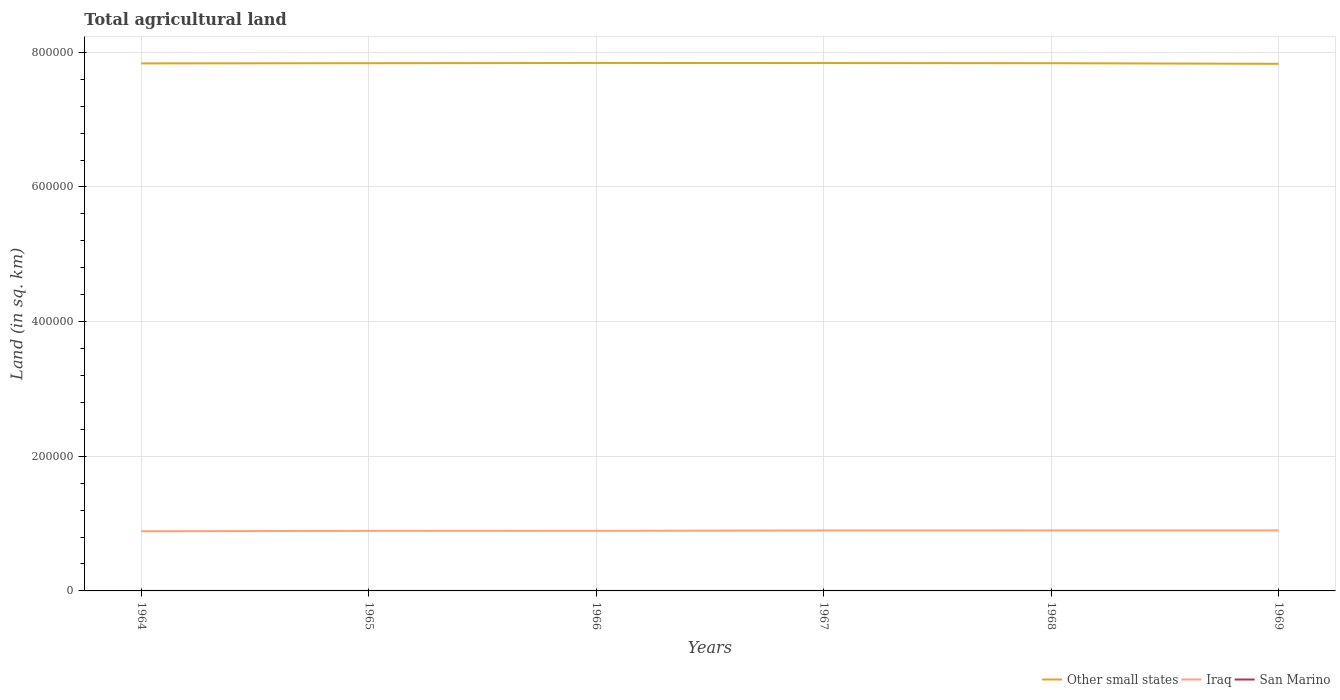How many different coloured lines are there?
Offer a terse response. 3. Is the number of lines equal to the number of legend labels?
Offer a very short reply. Yes. Across all years, what is the maximum total agricultural land in San Marino?
Ensure brevity in your answer.  10. In which year was the total agricultural land in Iraq maximum?
Provide a short and direct response. 1964. What is the difference between the highest and the second highest total agricultural land in Iraq?
Ensure brevity in your answer.  1250. What is the difference between the highest and the lowest total agricultural land in San Marino?
Your answer should be very brief. 0. Is the total agricultural land in Other small states strictly greater than the total agricultural land in Iraq over the years?
Offer a terse response. No. Are the values on the major ticks of Y-axis written in scientific E-notation?
Your answer should be compact. No. Does the graph contain any zero values?
Your answer should be very brief. No. Where does the legend appear in the graph?
Ensure brevity in your answer.  Bottom right. How many legend labels are there?
Offer a very short reply. 3. What is the title of the graph?
Your answer should be very brief. Total agricultural land. What is the label or title of the X-axis?
Ensure brevity in your answer.  Years. What is the label or title of the Y-axis?
Provide a short and direct response. Land (in sq. km). What is the Land (in sq. km) of Other small states in 1964?
Provide a short and direct response. 7.84e+05. What is the Land (in sq. km) of Iraq in 1964?
Give a very brief answer. 8.86e+04. What is the Land (in sq. km) in Other small states in 1965?
Your answer should be very brief. 7.84e+05. What is the Land (in sq. km) in Iraq in 1965?
Ensure brevity in your answer.  8.92e+04. What is the Land (in sq. km) of San Marino in 1965?
Offer a very short reply. 10. What is the Land (in sq. km) in Other small states in 1966?
Your response must be concise. 7.84e+05. What is the Land (in sq. km) in Iraq in 1966?
Your answer should be compact. 8.92e+04. What is the Land (in sq. km) in Other small states in 1967?
Make the answer very short. 7.84e+05. What is the Land (in sq. km) in Iraq in 1967?
Make the answer very short. 8.98e+04. What is the Land (in sq. km) of San Marino in 1967?
Your response must be concise. 10. What is the Land (in sq. km) of Other small states in 1968?
Make the answer very short. 7.84e+05. What is the Land (in sq. km) of Iraq in 1968?
Offer a very short reply. 8.98e+04. What is the Land (in sq. km) of Other small states in 1969?
Your answer should be very brief. 7.83e+05. What is the Land (in sq. km) of Iraq in 1969?
Your answer should be very brief. 8.99e+04. Across all years, what is the maximum Land (in sq. km) of Other small states?
Give a very brief answer. 7.84e+05. Across all years, what is the maximum Land (in sq. km) in Iraq?
Provide a short and direct response. 8.99e+04. Across all years, what is the maximum Land (in sq. km) in San Marino?
Your answer should be compact. 10. Across all years, what is the minimum Land (in sq. km) in Other small states?
Keep it short and to the point. 7.83e+05. Across all years, what is the minimum Land (in sq. km) in Iraq?
Offer a very short reply. 8.86e+04. What is the total Land (in sq. km) of Other small states in the graph?
Your answer should be compact. 4.70e+06. What is the total Land (in sq. km) in Iraq in the graph?
Make the answer very short. 5.37e+05. What is the total Land (in sq. km) in San Marino in the graph?
Ensure brevity in your answer.  60. What is the difference between the Land (in sq. km) of Other small states in 1964 and that in 1965?
Ensure brevity in your answer.  -270. What is the difference between the Land (in sq. km) in Iraq in 1964 and that in 1965?
Your answer should be very brief. -550. What is the difference between the Land (in sq. km) of San Marino in 1964 and that in 1965?
Offer a terse response. 0. What is the difference between the Land (in sq. km) in Other small states in 1964 and that in 1966?
Ensure brevity in your answer.  -610. What is the difference between the Land (in sq. km) in Iraq in 1964 and that in 1966?
Your answer should be very brief. -600. What is the difference between the Land (in sq. km) of San Marino in 1964 and that in 1966?
Offer a terse response. 0. What is the difference between the Land (in sq. km) of Other small states in 1964 and that in 1967?
Offer a terse response. -530. What is the difference between the Land (in sq. km) of Iraq in 1964 and that in 1967?
Keep it short and to the point. -1150. What is the difference between the Land (in sq. km) of San Marino in 1964 and that in 1967?
Your answer should be compact. 0. What is the difference between the Land (in sq. km) of Other small states in 1964 and that in 1968?
Your answer should be very brief. -270. What is the difference between the Land (in sq. km) of Iraq in 1964 and that in 1968?
Give a very brief answer. -1200. What is the difference between the Land (in sq. km) of Other small states in 1964 and that in 1969?
Give a very brief answer. 640. What is the difference between the Land (in sq. km) in Iraq in 1964 and that in 1969?
Give a very brief answer. -1250. What is the difference between the Land (in sq. km) of San Marino in 1964 and that in 1969?
Give a very brief answer. 0. What is the difference between the Land (in sq. km) in Other small states in 1965 and that in 1966?
Make the answer very short. -340. What is the difference between the Land (in sq. km) in Other small states in 1965 and that in 1967?
Offer a terse response. -260. What is the difference between the Land (in sq. km) of Iraq in 1965 and that in 1967?
Your response must be concise. -600. What is the difference between the Land (in sq. km) of Other small states in 1965 and that in 1968?
Ensure brevity in your answer.  0. What is the difference between the Land (in sq. km) of Iraq in 1965 and that in 1968?
Provide a short and direct response. -650. What is the difference between the Land (in sq. km) of Other small states in 1965 and that in 1969?
Your response must be concise. 910. What is the difference between the Land (in sq. km) in Iraq in 1965 and that in 1969?
Your answer should be very brief. -700. What is the difference between the Land (in sq. km) in San Marino in 1965 and that in 1969?
Make the answer very short. 0. What is the difference between the Land (in sq. km) of Iraq in 1966 and that in 1967?
Ensure brevity in your answer.  -550. What is the difference between the Land (in sq. km) in San Marino in 1966 and that in 1967?
Make the answer very short. 0. What is the difference between the Land (in sq. km) in Other small states in 1966 and that in 1968?
Your answer should be very brief. 340. What is the difference between the Land (in sq. km) of Iraq in 1966 and that in 1968?
Your response must be concise. -600. What is the difference between the Land (in sq. km) in Other small states in 1966 and that in 1969?
Your answer should be compact. 1250. What is the difference between the Land (in sq. km) of Iraq in 1966 and that in 1969?
Give a very brief answer. -650. What is the difference between the Land (in sq. km) of Other small states in 1967 and that in 1968?
Provide a short and direct response. 260. What is the difference between the Land (in sq. km) of Iraq in 1967 and that in 1968?
Provide a short and direct response. -50. What is the difference between the Land (in sq. km) in Other small states in 1967 and that in 1969?
Keep it short and to the point. 1170. What is the difference between the Land (in sq. km) of Iraq in 1967 and that in 1969?
Offer a very short reply. -100. What is the difference between the Land (in sq. km) of San Marino in 1967 and that in 1969?
Offer a very short reply. 0. What is the difference between the Land (in sq. km) in Other small states in 1968 and that in 1969?
Make the answer very short. 910. What is the difference between the Land (in sq. km) in Other small states in 1964 and the Land (in sq. km) in Iraq in 1965?
Keep it short and to the point. 6.94e+05. What is the difference between the Land (in sq. km) of Other small states in 1964 and the Land (in sq. km) of San Marino in 1965?
Your answer should be very brief. 7.84e+05. What is the difference between the Land (in sq. km) of Iraq in 1964 and the Land (in sq. km) of San Marino in 1965?
Provide a succinct answer. 8.86e+04. What is the difference between the Land (in sq. km) of Other small states in 1964 and the Land (in sq. km) of Iraq in 1966?
Your answer should be very brief. 6.94e+05. What is the difference between the Land (in sq. km) of Other small states in 1964 and the Land (in sq. km) of San Marino in 1966?
Provide a succinct answer. 7.84e+05. What is the difference between the Land (in sq. km) in Iraq in 1964 and the Land (in sq. km) in San Marino in 1966?
Offer a terse response. 8.86e+04. What is the difference between the Land (in sq. km) in Other small states in 1964 and the Land (in sq. km) in Iraq in 1967?
Offer a terse response. 6.94e+05. What is the difference between the Land (in sq. km) of Other small states in 1964 and the Land (in sq. km) of San Marino in 1967?
Offer a very short reply. 7.84e+05. What is the difference between the Land (in sq. km) in Iraq in 1964 and the Land (in sq. km) in San Marino in 1967?
Your response must be concise. 8.86e+04. What is the difference between the Land (in sq. km) in Other small states in 1964 and the Land (in sq. km) in Iraq in 1968?
Offer a very short reply. 6.94e+05. What is the difference between the Land (in sq. km) of Other small states in 1964 and the Land (in sq. km) of San Marino in 1968?
Your response must be concise. 7.84e+05. What is the difference between the Land (in sq. km) of Iraq in 1964 and the Land (in sq. km) of San Marino in 1968?
Provide a succinct answer. 8.86e+04. What is the difference between the Land (in sq. km) in Other small states in 1964 and the Land (in sq. km) in Iraq in 1969?
Your answer should be compact. 6.94e+05. What is the difference between the Land (in sq. km) of Other small states in 1964 and the Land (in sq. km) of San Marino in 1969?
Give a very brief answer. 7.84e+05. What is the difference between the Land (in sq. km) in Iraq in 1964 and the Land (in sq. km) in San Marino in 1969?
Provide a short and direct response. 8.86e+04. What is the difference between the Land (in sq. km) in Other small states in 1965 and the Land (in sq. km) in Iraq in 1966?
Provide a short and direct response. 6.95e+05. What is the difference between the Land (in sq. km) of Other small states in 1965 and the Land (in sq. km) of San Marino in 1966?
Ensure brevity in your answer.  7.84e+05. What is the difference between the Land (in sq. km) of Iraq in 1965 and the Land (in sq. km) of San Marino in 1966?
Provide a short and direct response. 8.92e+04. What is the difference between the Land (in sq. km) of Other small states in 1965 and the Land (in sq. km) of Iraq in 1967?
Offer a very short reply. 6.94e+05. What is the difference between the Land (in sq. km) in Other small states in 1965 and the Land (in sq. km) in San Marino in 1967?
Your answer should be very brief. 7.84e+05. What is the difference between the Land (in sq. km) in Iraq in 1965 and the Land (in sq. km) in San Marino in 1967?
Make the answer very short. 8.92e+04. What is the difference between the Land (in sq. km) in Other small states in 1965 and the Land (in sq. km) in Iraq in 1968?
Give a very brief answer. 6.94e+05. What is the difference between the Land (in sq. km) in Other small states in 1965 and the Land (in sq. km) in San Marino in 1968?
Your response must be concise. 7.84e+05. What is the difference between the Land (in sq. km) in Iraq in 1965 and the Land (in sq. km) in San Marino in 1968?
Your response must be concise. 8.92e+04. What is the difference between the Land (in sq. km) of Other small states in 1965 and the Land (in sq. km) of Iraq in 1969?
Keep it short and to the point. 6.94e+05. What is the difference between the Land (in sq. km) of Other small states in 1965 and the Land (in sq. km) of San Marino in 1969?
Make the answer very short. 7.84e+05. What is the difference between the Land (in sq. km) in Iraq in 1965 and the Land (in sq. km) in San Marino in 1969?
Keep it short and to the point. 8.92e+04. What is the difference between the Land (in sq. km) in Other small states in 1966 and the Land (in sq. km) in Iraq in 1967?
Offer a terse response. 6.94e+05. What is the difference between the Land (in sq. km) in Other small states in 1966 and the Land (in sq. km) in San Marino in 1967?
Offer a terse response. 7.84e+05. What is the difference between the Land (in sq. km) of Iraq in 1966 and the Land (in sq. km) of San Marino in 1967?
Your answer should be compact. 8.92e+04. What is the difference between the Land (in sq. km) of Other small states in 1966 and the Land (in sq. km) of Iraq in 1968?
Your answer should be compact. 6.94e+05. What is the difference between the Land (in sq. km) in Other small states in 1966 and the Land (in sq. km) in San Marino in 1968?
Your answer should be compact. 7.84e+05. What is the difference between the Land (in sq. km) in Iraq in 1966 and the Land (in sq. km) in San Marino in 1968?
Your answer should be very brief. 8.92e+04. What is the difference between the Land (in sq. km) of Other small states in 1966 and the Land (in sq. km) of Iraq in 1969?
Ensure brevity in your answer.  6.94e+05. What is the difference between the Land (in sq. km) in Other small states in 1966 and the Land (in sq. km) in San Marino in 1969?
Your response must be concise. 7.84e+05. What is the difference between the Land (in sq. km) of Iraq in 1966 and the Land (in sq. km) of San Marino in 1969?
Make the answer very short. 8.92e+04. What is the difference between the Land (in sq. km) of Other small states in 1967 and the Land (in sq. km) of Iraq in 1968?
Offer a very short reply. 6.94e+05. What is the difference between the Land (in sq. km) of Other small states in 1967 and the Land (in sq. km) of San Marino in 1968?
Give a very brief answer. 7.84e+05. What is the difference between the Land (in sq. km) in Iraq in 1967 and the Land (in sq. km) in San Marino in 1968?
Offer a very short reply. 8.98e+04. What is the difference between the Land (in sq. km) in Other small states in 1967 and the Land (in sq. km) in Iraq in 1969?
Your answer should be compact. 6.94e+05. What is the difference between the Land (in sq. km) in Other small states in 1967 and the Land (in sq. km) in San Marino in 1969?
Ensure brevity in your answer.  7.84e+05. What is the difference between the Land (in sq. km) of Iraq in 1967 and the Land (in sq. km) of San Marino in 1969?
Offer a terse response. 8.98e+04. What is the difference between the Land (in sq. km) of Other small states in 1968 and the Land (in sq. km) of Iraq in 1969?
Offer a terse response. 6.94e+05. What is the difference between the Land (in sq. km) of Other small states in 1968 and the Land (in sq. km) of San Marino in 1969?
Offer a terse response. 7.84e+05. What is the difference between the Land (in sq. km) in Iraq in 1968 and the Land (in sq. km) in San Marino in 1969?
Make the answer very short. 8.98e+04. What is the average Land (in sq. km) of Other small states per year?
Make the answer very short. 7.84e+05. What is the average Land (in sq. km) in Iraq per year?
Your answer should be very brief. 8.94e+04. In the year 1964, what is the difference between the Land (in sq. km) of Other small states and Land (in sq. km) of Iraq?
Ensure brevity in your answer.  6.95e+05. In the year 1964, what is the difference between the Land (in sq. km) of Other small states and Land (in sq. km) of San Marino?
Your response must be concise. 7.84e+05. In the year 1964, what is the difference between the Land (in sq. km) of Iraq and Land (in sq. km) of San Marino?
Your answer should be compact. 8.86e+04. In the year 1965, what is the difference between the Land (in sq. km) in Other small states and Land (in sq. km) in Iraq?
Give a very brief answer. 6.95e+05. In the year 1965, what is the difference between the Land (in sq. km) of Other small states and Land (in sq. km) of San Marino?
Your answer should be compact. 7.84e+05. In the year 1965, what is the difference between the Land (in sq. km) in Iraq and Land (in sq. km) in San Marino?
Provide a short and direct response. 8.92e+04. In the year 1966, what is the difference between the Land (in sq. km) in Other small states and Land (in sq. km) in Iraq?
Your answer should be very brief. 6.95e+05. In the year 1966, what is the difference between the Land (in sq. km) in Other small states and Land (in sq. km) in San Marino?
Provide a short and direct response. 7.84e+05. In the year 1966, what is the difference between the Land (in sq. km) in Iraq and Land (in sq. km) in San Marino?
Your response must be concise. 8.92e+04. In the year 1967, what is the difference between the Land (in sq. km) in Other small states and Land (in sq. km) in Iraq?
Your answer should be very brief. 6.94e+05. In the year 1967, what is the difference between the Land (in sq. km) in Other small states and Land (in sq. km) in San Marino?
Offer a terse response. 7.84e+05. In the year 1967, what is the difference between the Land (in sq. km) of Iraq and Land (in sq. km) of San Marino?
Make the answer very short. 8.98e+04. In the year 1968, what is the difference between the Land (in sq. km) of Other small states and Land (in sq. km) of Iraq?
Your response must be concise. 6.94e+05. In the year 1968, what is the difference between the Land (in sq. km) of Other small states and Land (in sq. km) of San Marino?
Make the answer very short. 7.84e+05. In the year 1968, what is the difference between the Land (in sq. km) in Iraq and Land (in sq. km) in San Marino?
Your response must be concise. 8.98e+04. In the year 1969, what is the difference between the Land (in sq. km) of Other small states and Land (in sq. km) of Iraq?
Your answer should be very brief. 6.93e+05. In the year 1969, what is the difference between the Land (in sq. km) of Other small states and Land (in sq. km) of San Marino?
Offer a terse response. 7.83e+05. In the year 1969, what is the difference between the Land (in sq. km) in Iraq and Land (in sq. km) in San Marino?
Your answer should be compact. 8.99e+04. What is the ratio of the Land (in sq. km) in Other small states in 1964 to that in 1965?
Your answer should be very brief. 1. What is the ratio of the Land (in sq. km) in Iraq in 1964 to that in 1965?
Your response must be concise. 0.99. What is the ratio of the Land (in sq. km) in Iraq in 1964 to that in 1966?
Offer a terse response. 0.99. What is the ratio of the Land (in sq. km) in San Marino in 1964 to that in 1966?
Provide a succinct answer. 1. What is the ratio of the Land (in sq. km) in Iraq in 1964 to that in 1967?
Offer a very short reply. 0.99. What is the ratio of the Land (in sq. km) in San Marino in 1964 to that in 1967?
Provide a succinct answer. 1. What is the ratio of the Land (in sq. km) in Other small states in 1964 to that in 1968?
Ensure brevity in your answer.  1. What is the ratio of the Land (in sq. km) of Iraq in 1964 to that in 1968?
Provide a short and direct response. 0.99. What is the ratio of the Land (in sq. km) in San Marino in 1964 to that in 1968?
Make the answer very short. 1. What is the ratio of the Land (in sq. km) in Iraq in 1964 to that in 1969?
Give a very brief answer. 0.99. What is the ratio of the Land (in sq. km) of Other small states in 1965 to that in 1966?
Your response must be concise. 1. What is the ratio of the Land (in sq. km) in San Marino in 1965 to that in 1966?
Make the answer very short. 1. What is the ratio of the Land (in sq. km) of Other small states in 1965 to that in 1967?
Keep it short and to the point. 1. What is the ratio of the Land (in sq. km) in Iraq in 1965 to that in 1967?
Offer a terse response. 0.99. What is the ratio of the Land (in sq. km) of Iraq in 1965 to that in 1968?
Make the answer very short. 0.99. What is the ratio of the Land (in sq. km) in Iraq in 1965 to that in 1969?
Your answer should be compact. 0.99. What is the ratio of the Land (in sq. km) of Other small states in 1966 to that in 1967?
Your response must be concise. 1. What is the ratio of the Land (in sq. km) in Iraq in 1966 to that in 1967?
Ensure brevity in your answer.  0.99. What is the ratio of the Land (in sq. km) in Other small states in 1966 to that in 1968?
Your answer should be very brief. 1. What is the ratio of the Land (in sq. km) in San Marino in 1966 to that in 1969?
Your answer should be very brief. 1. What is the ratio of the Land (in sq. km) in Other small states in 1967 to that in 1968?
Make the answer very short. 1. What is the ratio of the Land (in sq. km) in Other small states in 1968 to that in 1969?
Your answer should be compact. 1. What is the difference between the highest and the lowest Land (in sq. km) of Other small states?
Provide a succinct answer. 1250. What is the difference between the highest and the lowest Land (in sq. km) of Iraq?
Provide a short and direct response. 1250. 